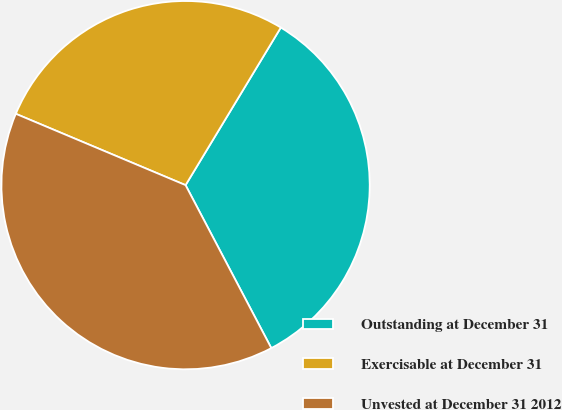<chart> <loc_0><loc_0><loc_500><loc_500><pie_chart><fcel>Outstanding at December 31<fcel>Exercisable at December 31<fcel>Unvested at December 31 2012<nl><fcel>33.64%<fcel>27.32%<fcel>39.04%<nl></chart> 